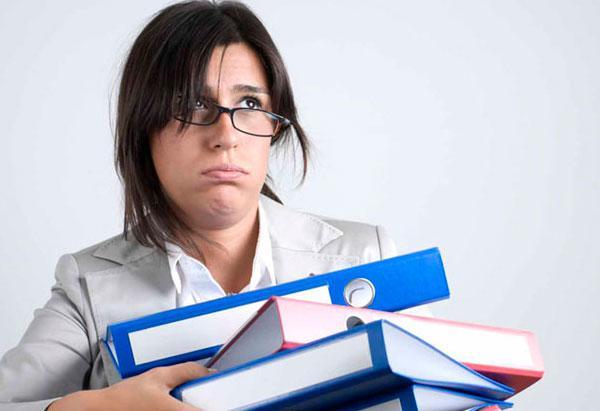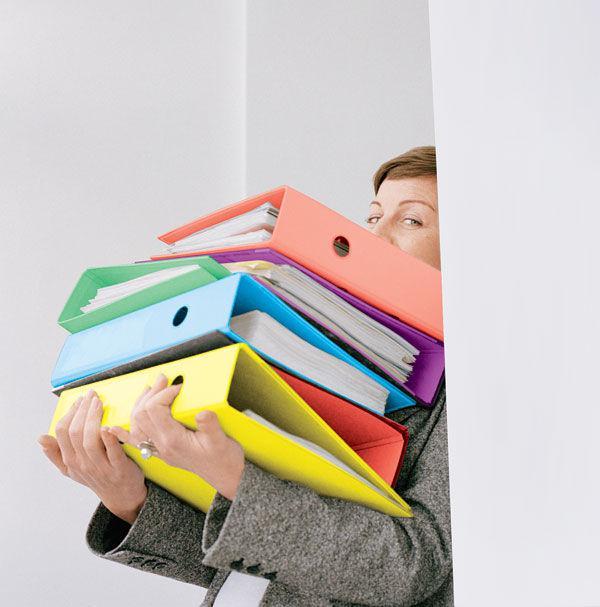The first image is the image on the left, the second image is the image on the right. Analyze the images presented: Is the assertion "Right image shows multiple different solid colored binders of the same size." valid? Answer yes or no. Yes. 